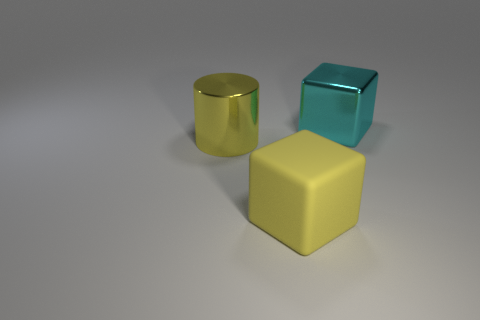What is the material of the other object that is the same color as the big matte thing?
Give a very brief answer. Metal. There is a block in front of the large cyan block that is behind the metallic object that is on the left side of the rubber object; what is it made of?
Your answer should be compact. Rubber. What size is the rubber thing that is the same color as the shiny cylinder?
Ensure brevity in your answer.  Large. What material is the cylinder?
Give a very brief answer. Metal. Are the big cylinder and the block that is left of the cyan cube made of the same material?
Offer a terse response. No. There is a thing in front of the shiny object that is left of the cyan metallic cube; what color is it?
Give a very brief answer. Yellow. What is the size of the thing that is behind the yellow matte cube and to the right of the big yellow shiny thing?
Make the answer very short. Large. How many other things are there of the same shape as the large cyan object?
Keep it short and to the point. 1. Do the cyan metal object and the yellow thing that is behind the big yellow matte object have the same shape?
Your answer should be very brief. No. There is a big yellow metallic thing; what number of cyan metallic blocks are to the left of it?
Keep it short and to the point. 0. 